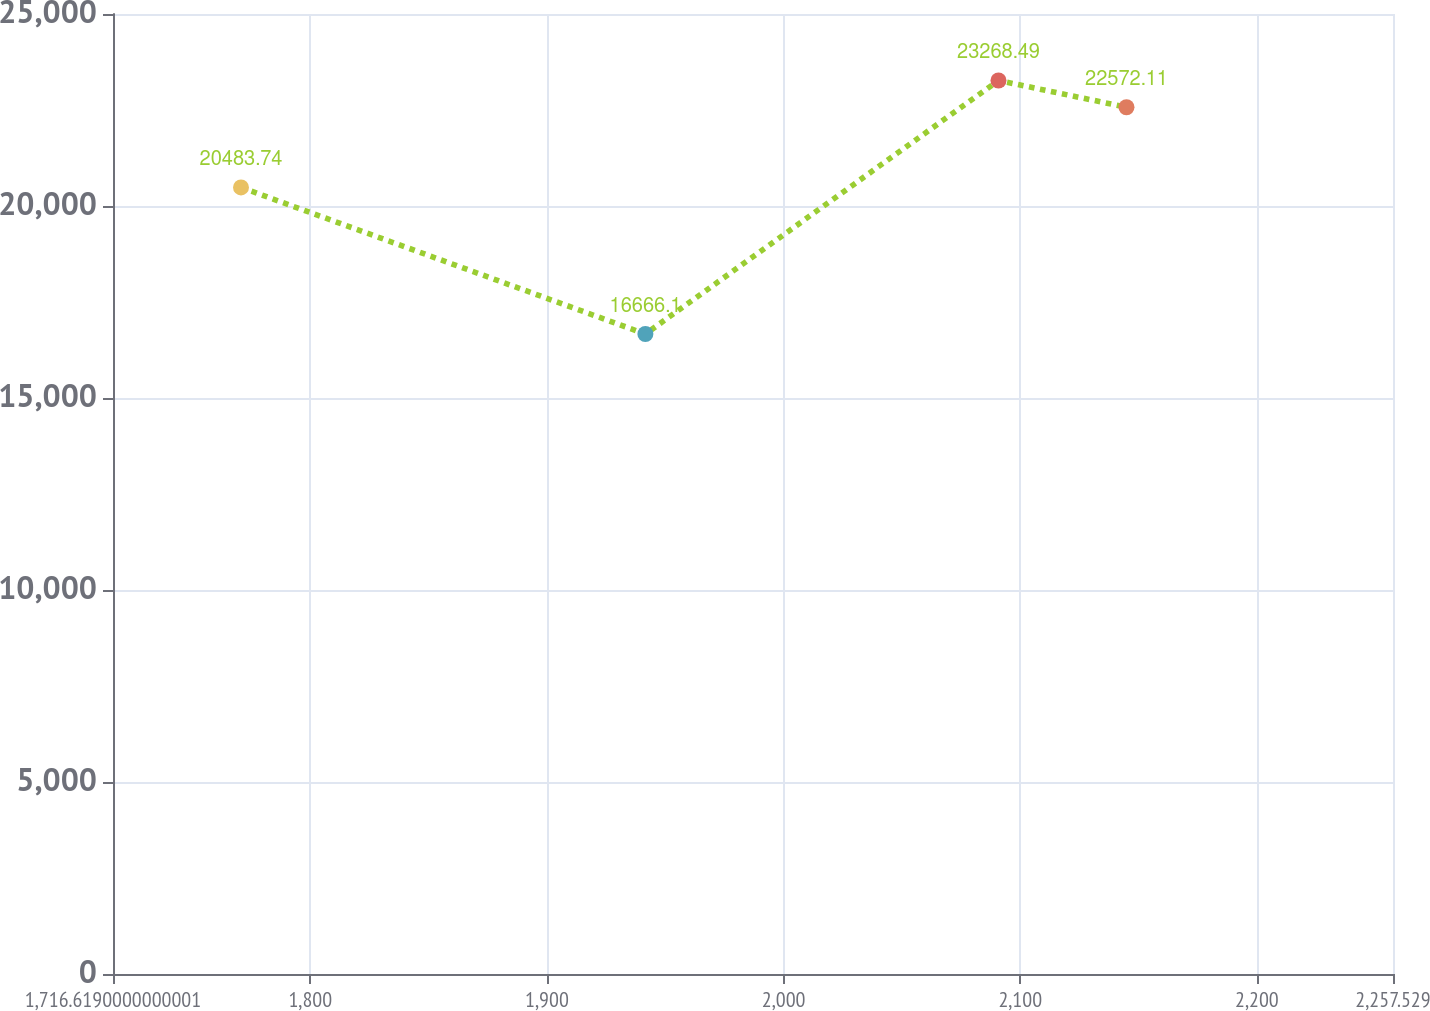Convert chart. <chart><loc_0><loc_0><loc_500><loc_500><line_chart><ecel><fcel>Unnamed: 1<nl><fcel>1770.71<fcel>20483.7<nl><fcel>1941.6<fcel>16666.1<nl><fcel>2090.81<fcel>23268.5<nl><fcel>2144.9<fcel>22572.1<nl><fcel>2311.62<fcel>23964.9<nl></chart> 